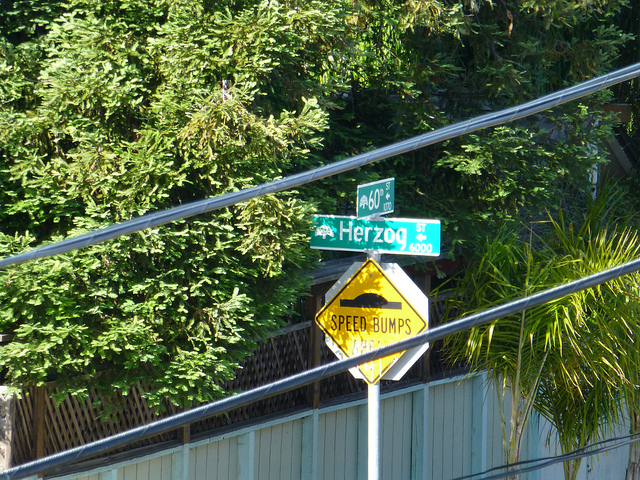Read and extract the text from this image. 60 Herzog 6000 SPEED BUMPS 